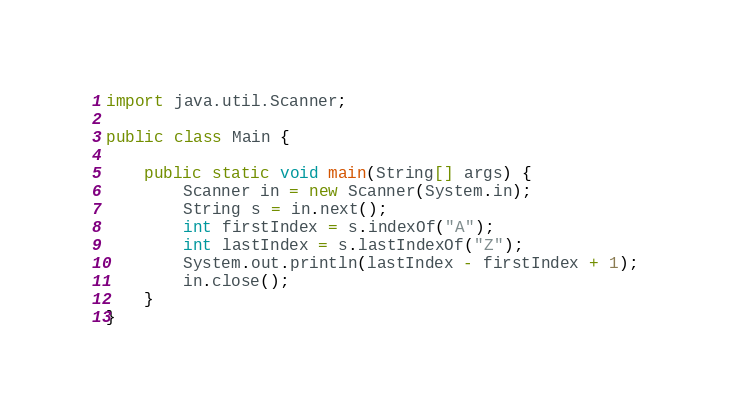<code> <loc_0><loc_0><loc_500><loc_500><_Java_>import java.util.Scanner;

public class Main {

	public static void main(String[] args) {
		Scanner in = new Scanner(System.in);
		String s = in.next();
		int firstIndex = s.indexOf("A");
		int lastIndex = s.lastIndexOf("Z");
		System.out.println(lastIndex - firstIndex + 1);
		in.close();
	}
}</code> 